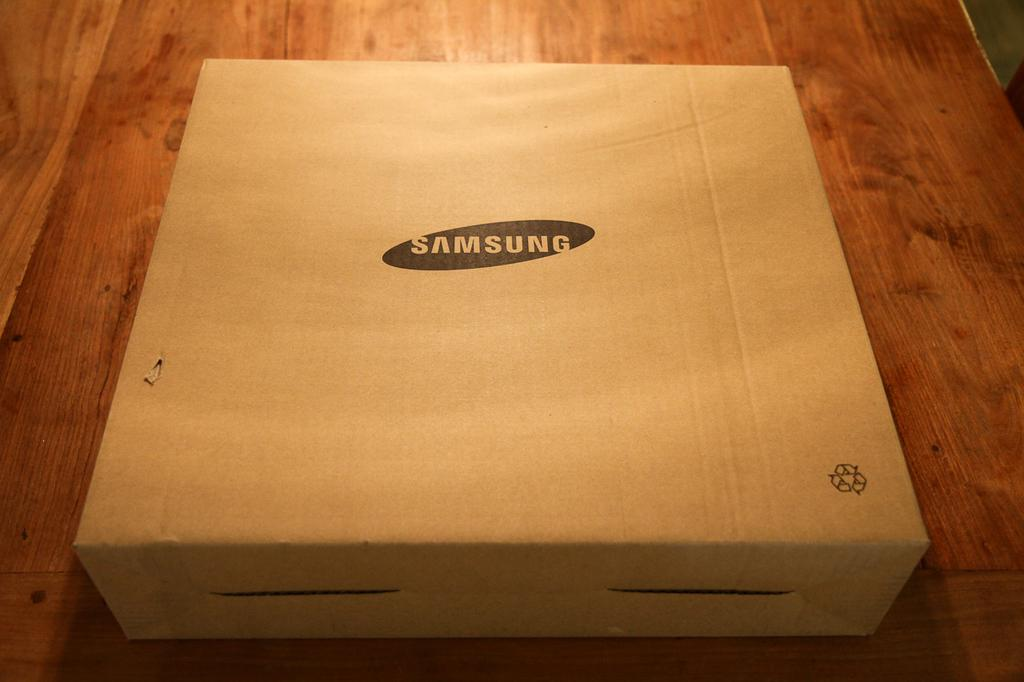<image>
Provide a brief description of the given image. A box from Samsung that looks like a pizza box but smaller. 